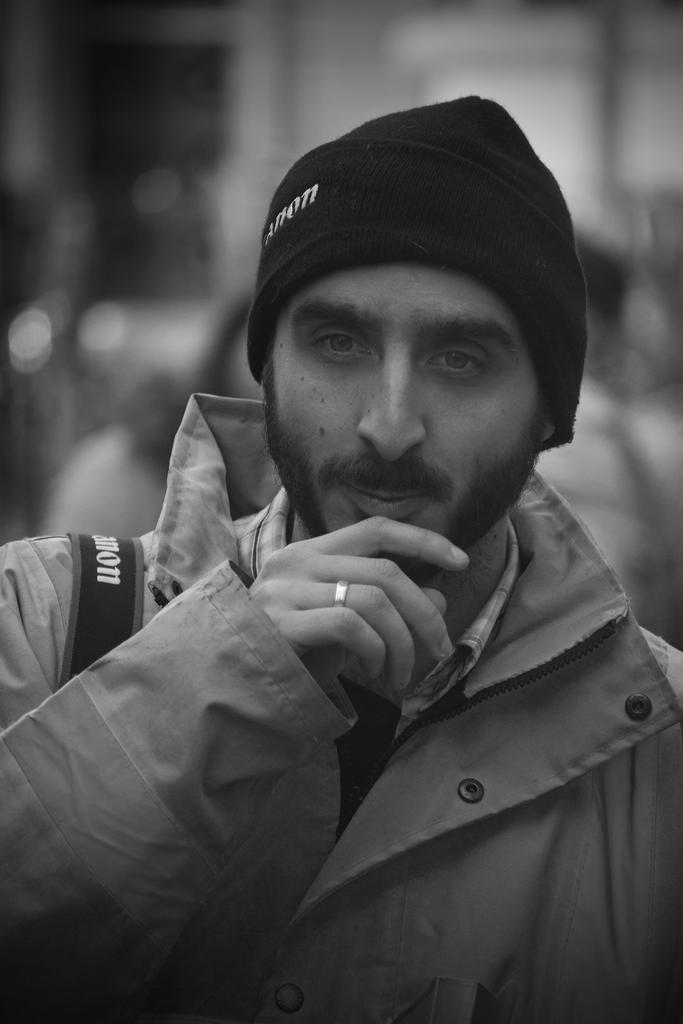Who is the main subject in the foreground of the image? There is a man in the foreground of the image. What can be seen in the background of the image? There is a wall in the background of the image. Can you describe the setting where the image might have been taken? The image may have been taken in a hall, based on the presence of a wall in the background. Reasoning: Let'g: Let's think step by step in order to produce the conversation. We start by identifying the main subject in the image, which is the man in the foreground. Then, we describe the background of the image, which features a wall. Finally, we speculate on the setting of the image, suggesting that it might have been taken in a hall based on the presence of a wall. Absurd Question/Answer: Where is the kitty playing with a club in the image? There is no kitty or club present in the image. 